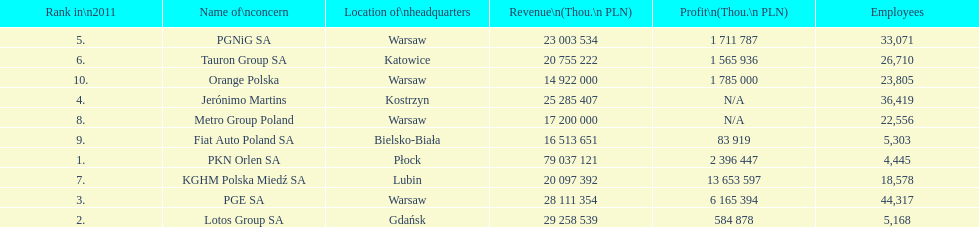What company has the top number of employees? PGE SA. 